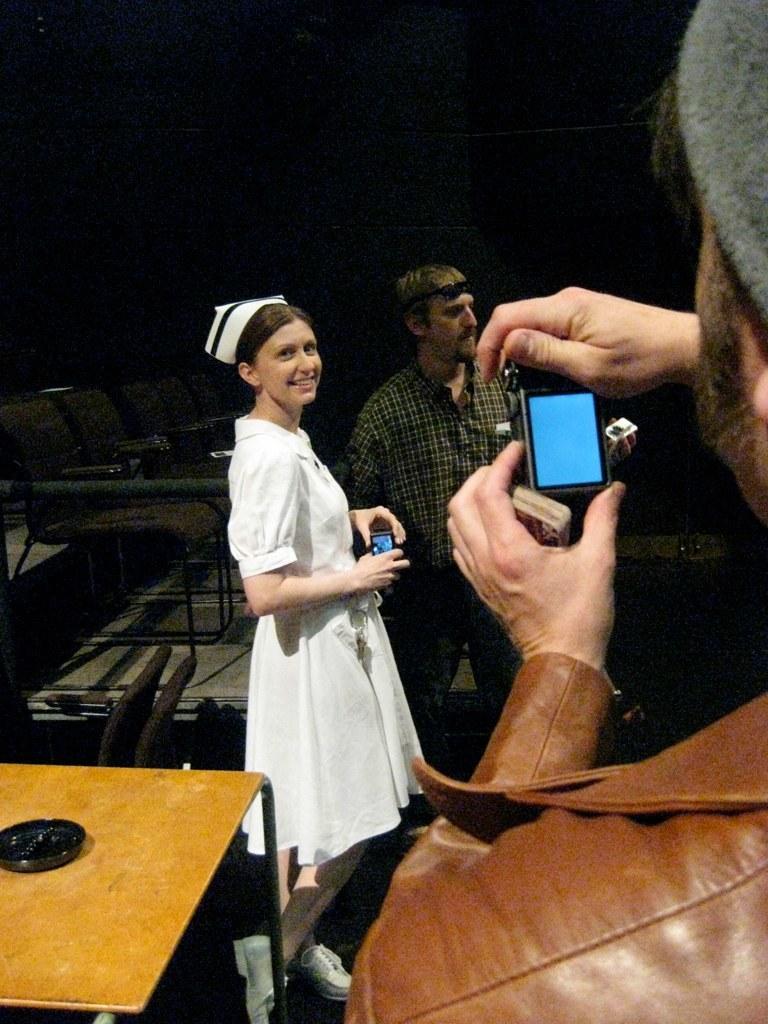How would you summarize this image in a sentence or two? In this image there is a woman wearing a white dress. She is holding a mobile in her hand. Beside her there is a person wearing a shirt. Right side there is a person holding a camera in his hand. Left side there is a table. Beside there are few benches on the floor. 